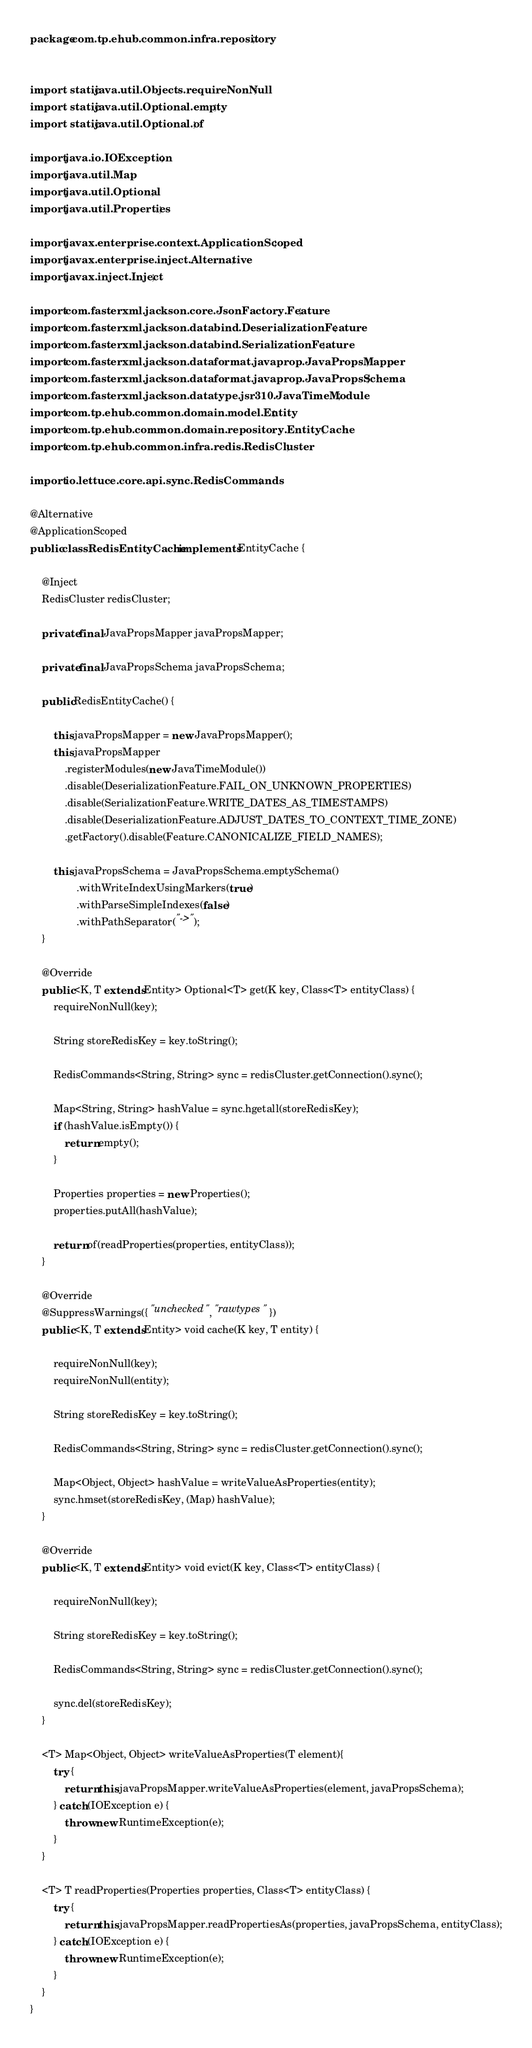<code> <loc_0><loc_0><loc_500><loc_500><_Java_>package com.tp.ehub.common.infra.repository;


import static java.util.Objects.requireNonNull;
import static java.util.Optional.empty;
import static java.util.Optional.of;

import java.io.IOException;
import java.util.Map;
import java.util.Optional;
import java.util.Properties;

import javax.enterprise.context.ApplicationScoped;
import javax.enterprise.inject.Alternative;
import javax.inject.Inject;

import com.fasterxml.jackson.core.JsonFactory.Feature;
import com.fasterxml.jackson.databind.DeserializationFeature;
import com.fasterxml.jackson.databind.SerializationFeature;
import com.fasterxml.jackson.dataformat.javaprop.JavaPropsMapper;
import com.fasterxml.jackson.dataformat.javaprop.JavaPropsSchema;
import com.fasterxml.jackson.datatype.jsr310.JavaTimeModule;
import com.tp.ehub.common.domain.model.Entity;
import com.tp.ehub.common.domain.repository.EntityCache;
import com.tp.ehub.common.infra.redis.RedisCluster;

import io.lettuce.core.api.sync.RedisCommands;

@Alternative
@ApplicationScoped
public class RedisEntityCache implements EntityCache {

	@Inject
	RedisCluster redisCluster;
	
	private final JavaPropsMapper javaPropsMapper;
	
	private final JavaPropsSchema javaPropsSchema;
		
	public RedisEntityCache() {
				
		this.javaPropsMapper = new JavaPropsMapper();
		this.javaPropsMapper
			.registerModules(new JavaTimeModule())
			.disable(DeserializationFeature.FAIL_ON_UNKNOWN_PROPERTIES)
			.disable(SerializationFeature.WRITE_DATES_AS_TIMESTAMPS)
			.disable(DeserializationFeature.ADJUST_DATES_TO_CONTEXT_TIME_ZONE)
			.getFactory().disable(Feature.CANONICALIZE_FIELD_NAMES);
		
		this.javaPropsSchema = JavaPropsSchema.emptySchema()
				.withWriteIndexUsingMarkers(true)
				.withParseSimpleIndexes(false)
				.withPathSeparator("->");
	}

	@Override
	public <K, T extends Entity> Optional<T> get(K key, Class<T> entityClass) {
		requireNonNull(key);

		String storeRedisKey = key.toString();

		RedisCommands<String, String> sync = redisCluster.getConnection().sync();
		
		Map<String, String> hashValue = sync.hgetall(storeRedisKey);
		if (hashValue.isEmpty()) {
			return empty();
		}

		Properties properties = new Properties();
		properties.putAll(hashValue);

		return of(readProperties(properties, entityClass));
	}

	@Override
	@SuppressWarnings({ "unchecked", "rawtypes" })
	public <K, T extends Entity> void cache(K key, T entity) {
		
		requireNonNull(key);
		requireNonNull(entity);
		
		String storeRedisKey = key.toString();
		
		RedisCommands<String, String> sync = redisCluster.getConnection().sync();
		
		Map<Object, Object> hashValue = writeValueAsProperties(entity);
		sync.hmset(storeRedisKey, (Map) hashValue);		
	}

	@Override
	public <K, T extends Entity> void evict(K key, Class<T> entityClass) {
		
		requireNonNull(key);

		String storeRedisKey = key.toString();

		RedisCommands<String, String> sync = redisCluster.getConnection().sync();

		sync.del(storeRedisKey);		
	}
	
	<T> Map<Object, Object> writeValueAsProperties(T element){
		try {
			return this.javaPropsMapper.writeValueAsProperties(element, javaPropsSchema);
		} catch (IOException e) {
			throw new RuntimeException(e);
		}
	}

	<T> T readProperties(Properties properties, Class<T> entityClass) {
		try {
			return this.javaPropsMapper.readPropertiesAs(properties, javaPropsSchema, entityClass);
		} catch (IOException e) {
			throw new RuntimeException(e);
		}
	}
}
</code> 